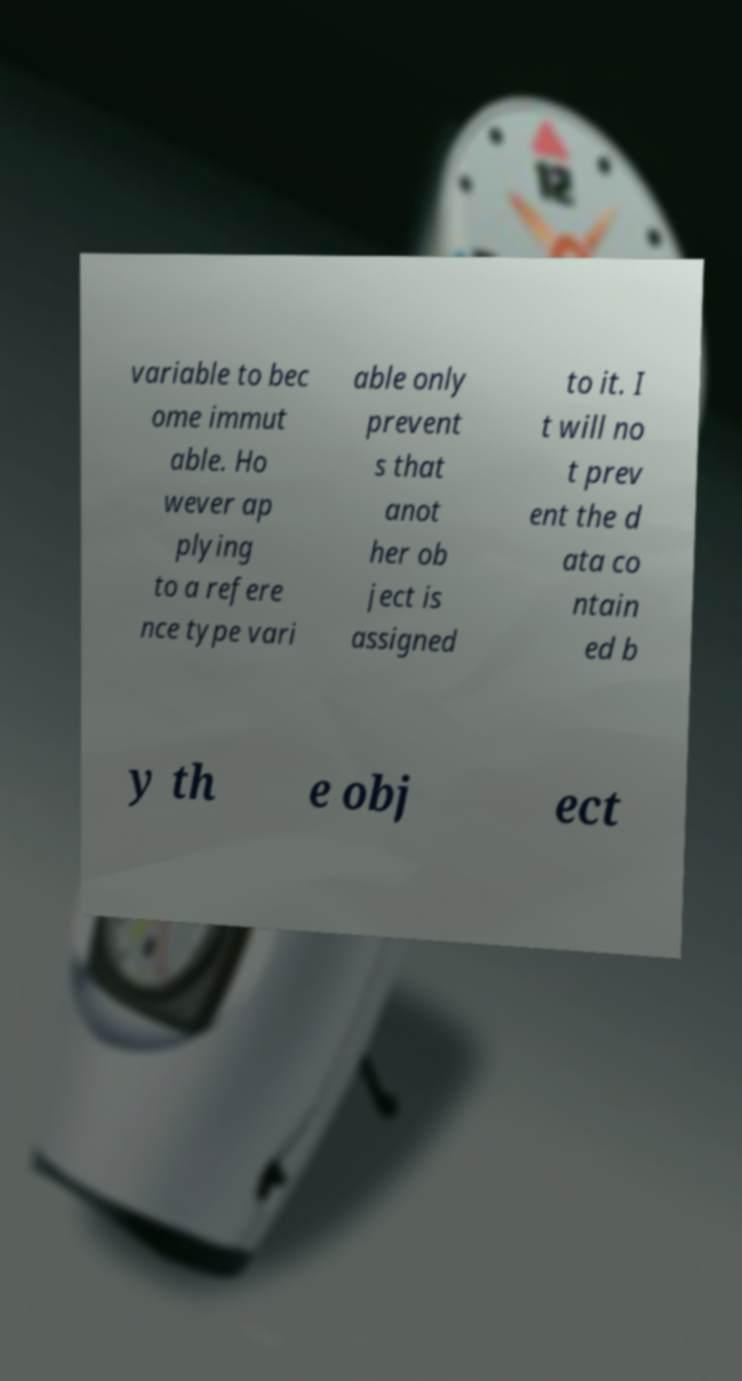Please read and relay the text visible in this image. What does it say? variable to bec ome immut able. Ho wever ap plying to a refere nce type vari able only prevent s that anot her ob ject is assigned to it. I t will no t prev ent the d ata co ntain ed b y th e obj ect 